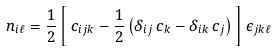Convert formula to latex. <formula><loc_0><loc_0><loc_500><loc_500>n _ { i \ell } = \frac { 1 } { 2 } \left [ \, c _ { i j k } - \frac { 1 } { 2 } \left ( \delta _ { i j } \, c _ { k } - \delta _ { i k } \, c _ { j } \right ) \, \right ] \epsilon _ { j k \ell }</formula> 